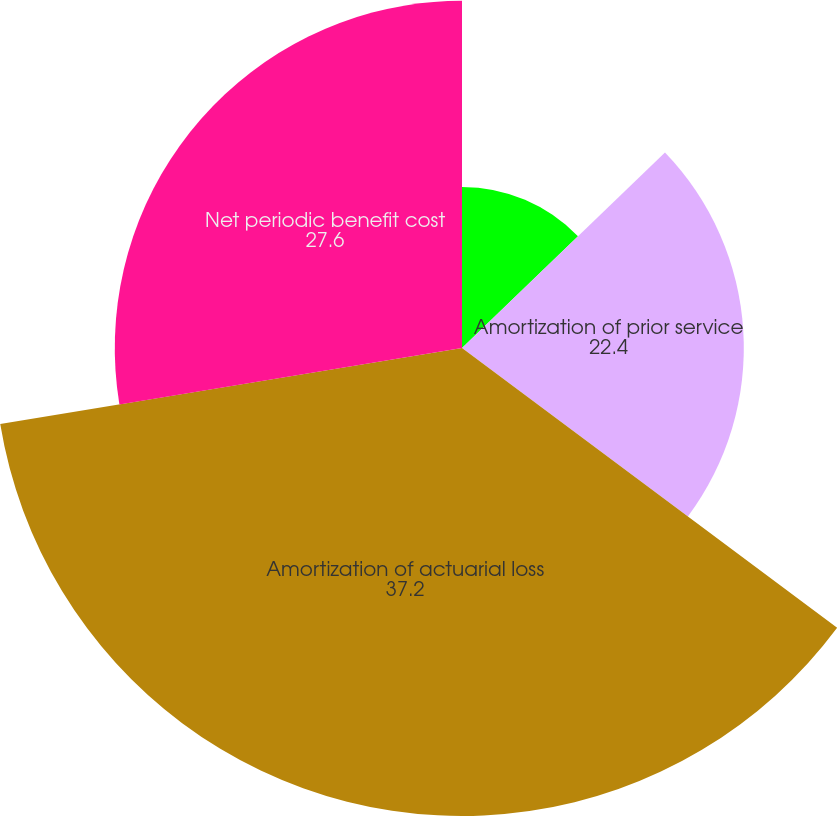Convert chart to OTSL. <chart><loc_0><loc_0><loc_500><loc_500><pie_chart><fcel>Interest cost<fcel>Amortization of prior service<fcel>Amortization of actuarial loss<fcel>Net periodic benefit cost<nl><fcel>12.8%<fcel>22.4%<fcel>37.2%<fcel>27.6%<nl></chart> 